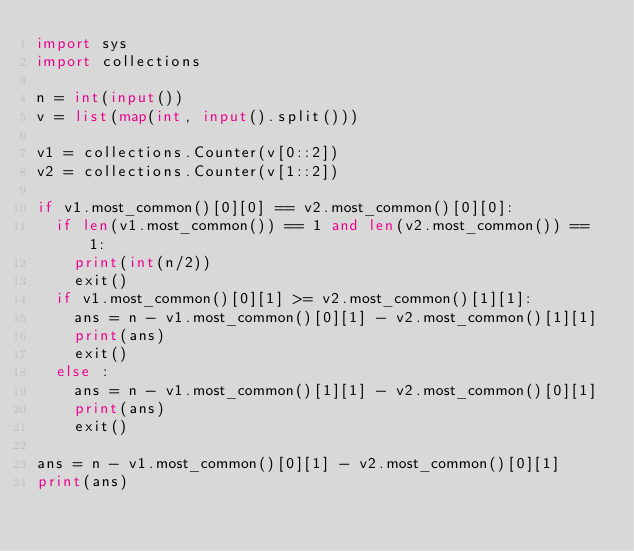<code> <loc_0><loc_0><loc_500><loc_500><_Python_>import sys 
import collections

n = int(input())
v = list(map(int, input().split()))

v1 = collections.Counter(v[0::2])
v2 = collections.Counter(v[1::2])

if v1.most_common()[0][0] == v2.most_common()[0][0]:
  if len(v1.most_common()) == 1 and len(v2.most_common()) == 1:
    print(int(n/2))
    exit()
  if v1.most_common()[0][1] >= v2.most_common()[1][1]:
    ans = n - v1.most_common()[0][1] - v2.most_common()[1][1]
    print(ans)
    exit()
  else :
    ans = n - v1.most_common()[1][1] - v2.most_common()[0][1]
    print(ans)
    exit()

ans = n - v1.most_common()[0][1] - v2.most_common()[0][1]
print(ans)</code> 